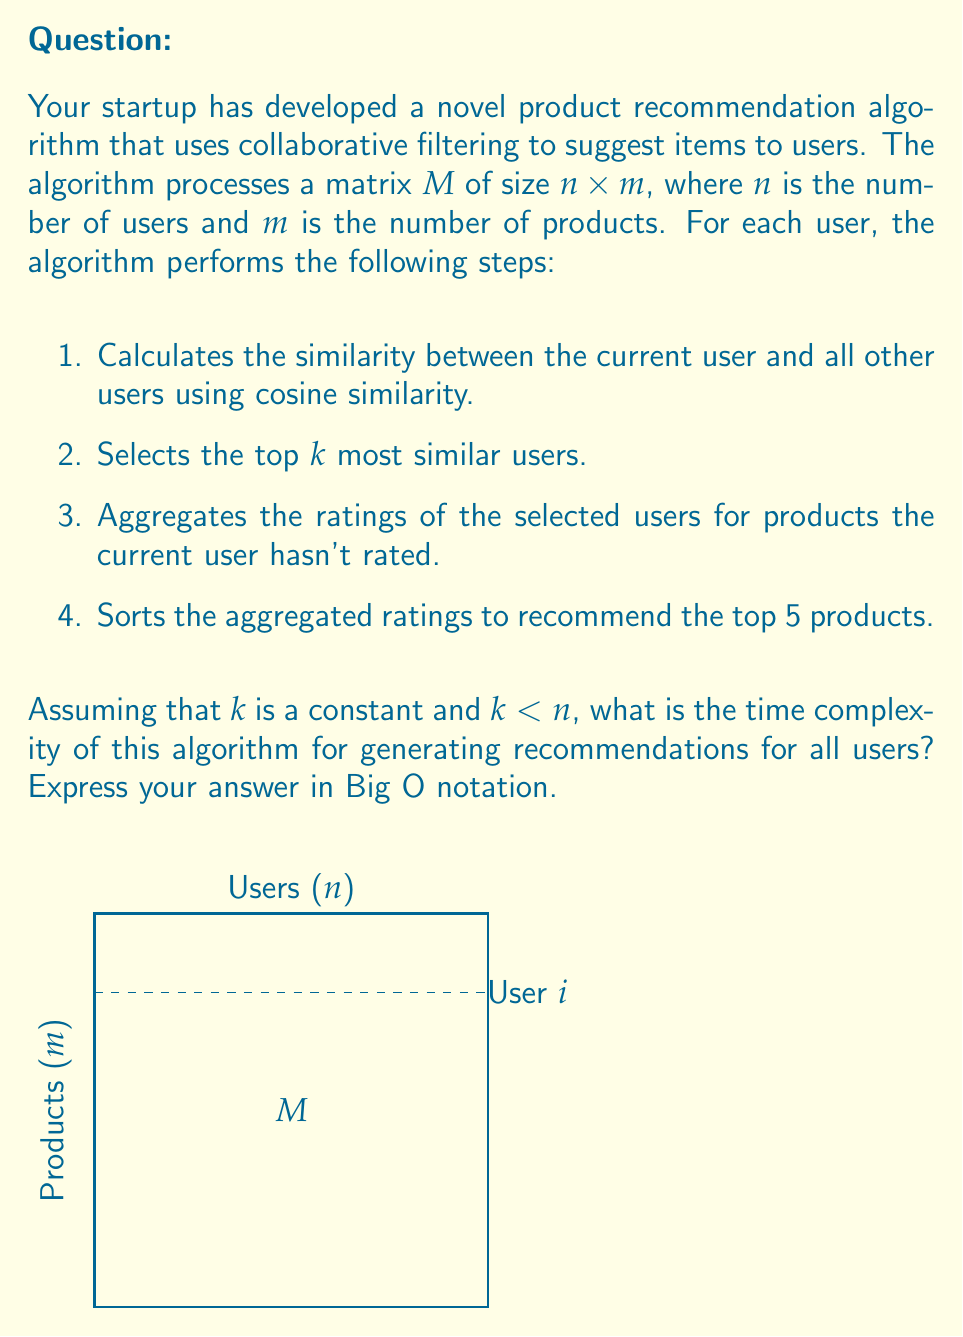Could you help me with this problem? Let's analyze the time complexity step by step:

1. Calculating similarity:
   - For each user, we need to compute the cosine similarity with all other users.
   - Cosine similarity calculation takes $O(m)$ time for each pair of users.
   - There are $n-1$ comparisons for each user.
   - Time complexity for this step: $O(n \cdot (n-1) \cdot m) = O(n^2m)$

2. Selecting top $k$ similar users:
   - We can use a min-heap of size $k$ to keep track of the top $k$ users.
   - Inserting into a heap of size $k$ takes $O(\log k)$ time.
   - We do this for all $n-1$ users.
   - Time complexity for this step: $O(n \cdot (n-1) \cdot \log k) = O(n^2 \log k)$

3. Aggregating ratings:
   - For each of the $k$ selected users, we aggregate their ratings.
   - This takes $O(km)$ time for each user.
   - Time complexity for this step: $O(nkm)$

4. Sorting aggregated ratings:
   - We need to sort at most $m$ aggregated ratings.
   - Using an efficient sorting algorithm, this takes $O(m \log m)$ time.
   - Time complexity for this step: $O(nm \log m)$

Now, we need to sum up these complexities and simplify:

$$O(n^2m + n^2 \log k + nkm + nm \log m)$$

Since $k$ is a constant, $\log k$ is also a constant. We can simplify further:

$$O(n^2m + nm \log m)$$

The dominant term here is $n^2m$, as it grows faster than $nm \log m$ for large values of $n$ and $m$.

Therefore, the overall time complexity of the algorithm for all users is $O(n^2m)$.
Answer: $O(n^2m)$ 